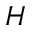Convert formula to latex. <formula><loc_0><loc_0><loc_500><loc_500>H</formula> 